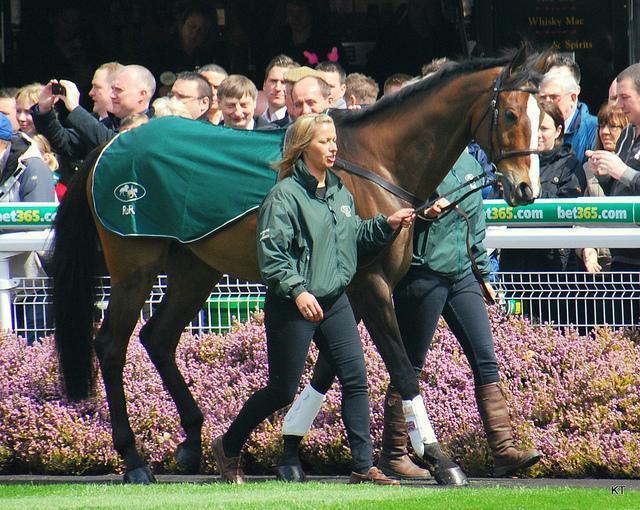How many people are visible?
Give a very brief answer. 9. 